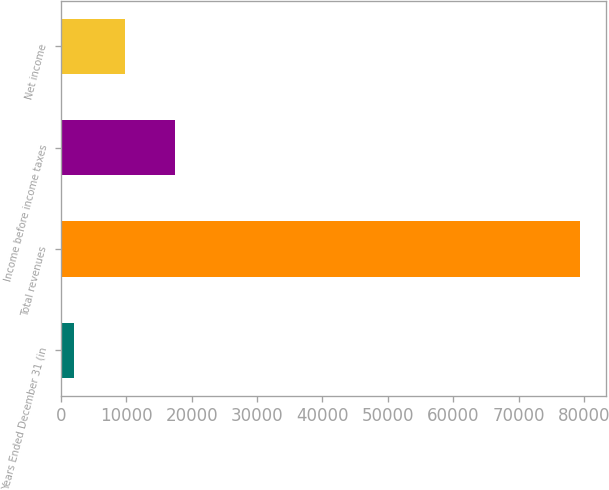Convert chart. <chart><loc_0><loc_0><loc_500><loc_500><bar_chart><fcel>Years Ended December 31 (in<fcel>Total revenues<fcel>Income before income taxes<fcel>Net income<nl><fcel>2003<fcel>79421<fcel>17486.6<fcel>9744.8<nl></chart> 